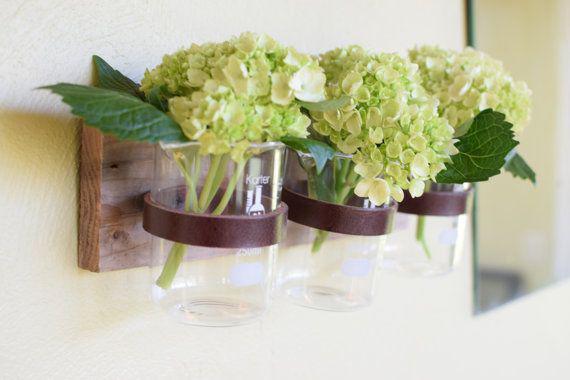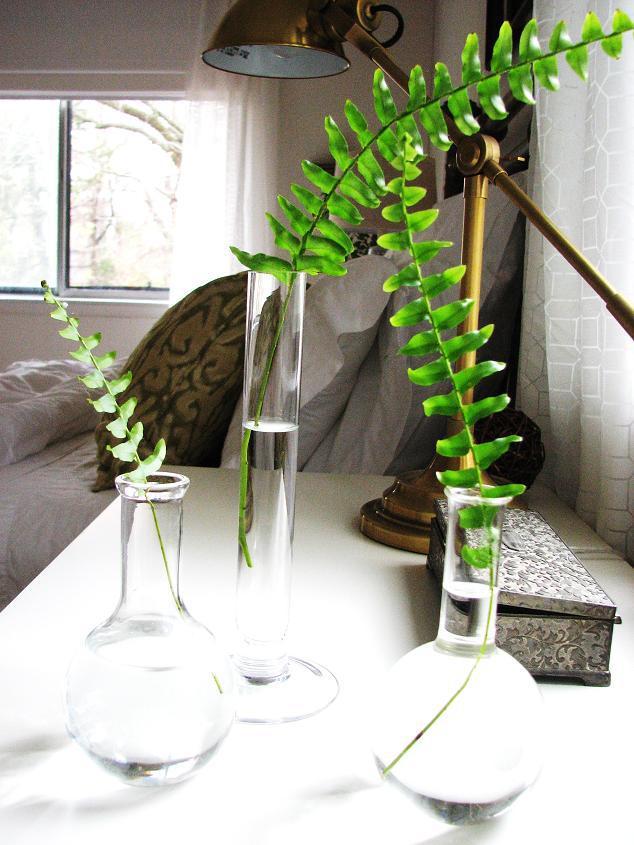The first image is the image on the left, the second image is the image on the right. For the images displayed, is the sentence "There is a total of 6 beakers and tubes with single plants or stems in it." factually correct? Answer yes or no. Yes. The first image is the image on the left, the second image is the image on the right. Given the left and right images, does the statement "There are exactly three plants in the left image." hold true? Answer yes or no. Yes. 